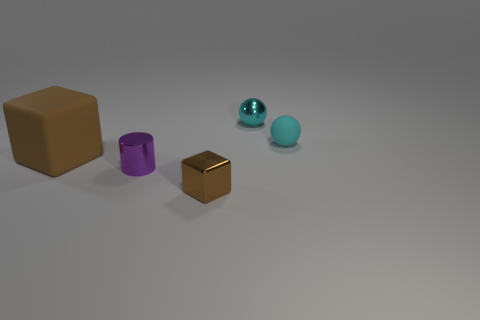There is a purple object; is its shape the same as the small thing that is on the right side of the cyan metal thing?
Offer a terse response. No. What number of other brown rubber objects are the same size as the brown matte thing?
Your answer should be compact. 0. There is a brown cube behind the metal object that is in front of the purple cylinder; what number of rubber cubes are in front of it?
Offer a very short reply. 0. Are there the same number of large brown rubber things that are on the left side of the small brown metallic object and big matte cubes on the left side of the large brown thing?
Ensure brevity in your answer.  No. What number of purple objects are the same shape as the tiny cyan metallic object?
Make the answer very short. 0. Is there another brown object made of the same material as the small brown object?
Offer a terse response. No. There is a tiny shiny object that is the same color as the small rubber ball; what is its shape?
Your answer should be compact. Sphere. How many cyan objects are there?
Your answer should be very brief. 2. What number of balls are brown rubber objects or small cyan rubber objects?
Your response must be concise. 1. The cylinder that is the same size as the shiny block is what color?
Keep it short and to the point. Purple. 